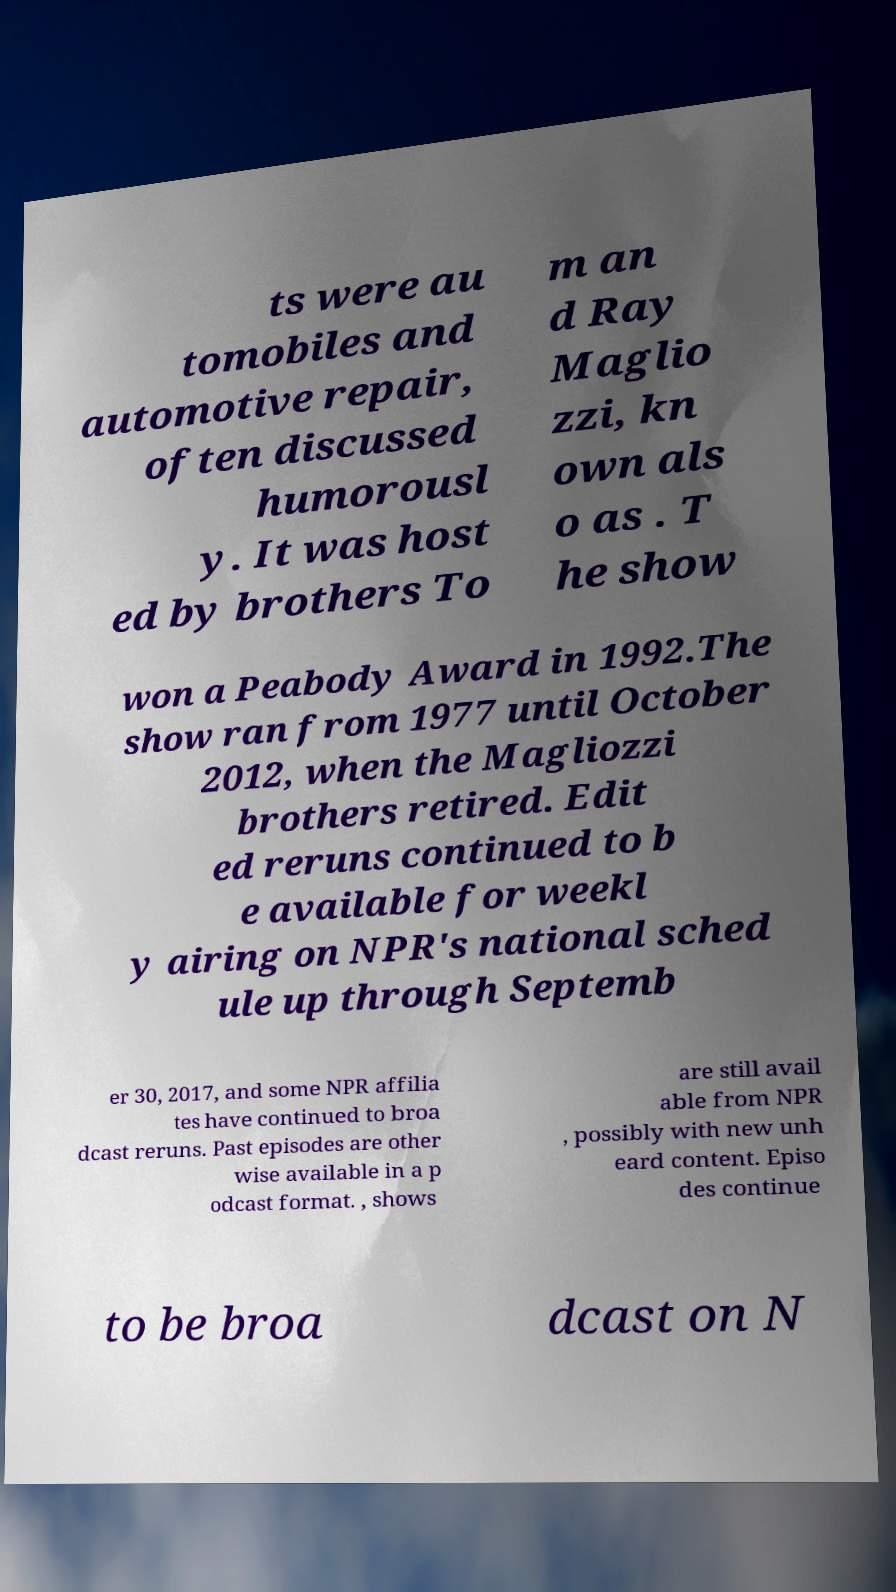Could you assist in decoding the text presented in this image and type it out clearly? ts were au tomobiles and automotive repair, often discussed humorousl y. It was host ed by brothers To m an d Ray Maglio zzi, kn own als o as . T he show won a Peabody Award in 1992.The show ran from 1977 until October 2012, when the Magliozzi brothers retired. Edit ed reruns continued to b e available for weekl y airing on NPR's national sched ule up through Septemb er 30, 2017, and some NPR affilia tes have continued to broa dcast reruns. Past episodes are other wise available in a p odcast format. , shows are still avail able from NPR , possibly with new unh eard content. Episo des continue to be broa dcast on N 